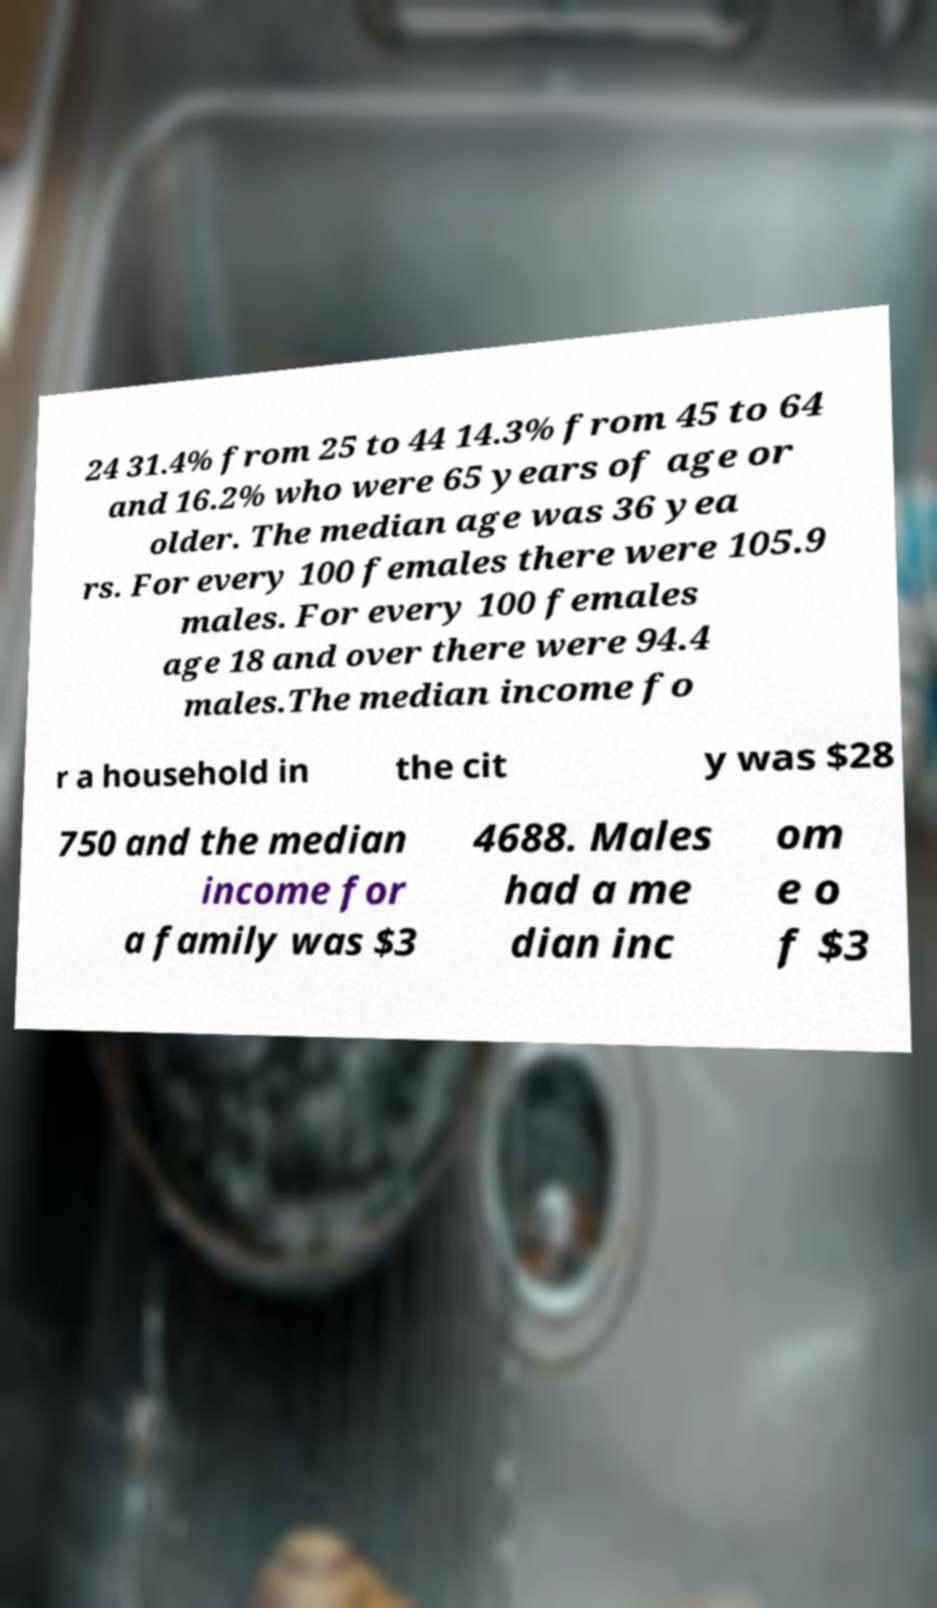Could you assist in decoding the text presented in this image and type it out clearly? 24 31.4% from 25 to 44 14.3% from 45 to 64 and 16.2% who were 65 years of age or older. The median age was 36 yea rs. For every 100 females there were 105.9 males. For every 100 females age 18 and over there were 94.4 males.The median income fo r a household in the cit y was $28 750 and the median income for a family was $3 4688. Males had a me dian inc om e o f $3 